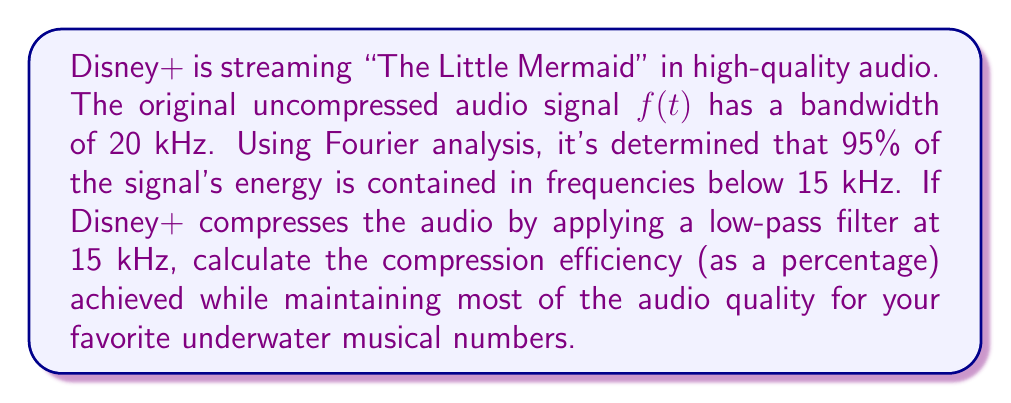Can you solve this math problem? To solve this problem, we'll use the concept of bandwidth compression in Fourier analysis:

1) The original bandwidth is 20 kHz.

2) After compression, the new bandwidth is 15 kHz.

3) The compression efficiency can be calculated using the formula:

   $$ \text{Compression Efficiency} = \frac{\text{Original Bandwidth} - \text{Compressed Bandwidth}}{\text{Original Bandwidth}} \times 100\% $$

4) Substituting the values:

   $$ \text{Compression Efficiency} = \frac{20\text{ kHz} - 15\text{ kHz}}{20\text{ kHz}} \times 100\% $$

5) Simplifying:

   $$ \text{Compression Efficiency} = \frac{5\text{ kHz}}{20\text{ kHz}} \times 100\% = 0.25 \times 100\% = 25\% $$

6) This compression maintains 95% of the signal's energy, ensuring that favorite songs like "Under the Sea" and "Part of Your World" still sound great while significantly reducing the data needed for streaming.
Answer: The compression efficiency achieved is 25%. 